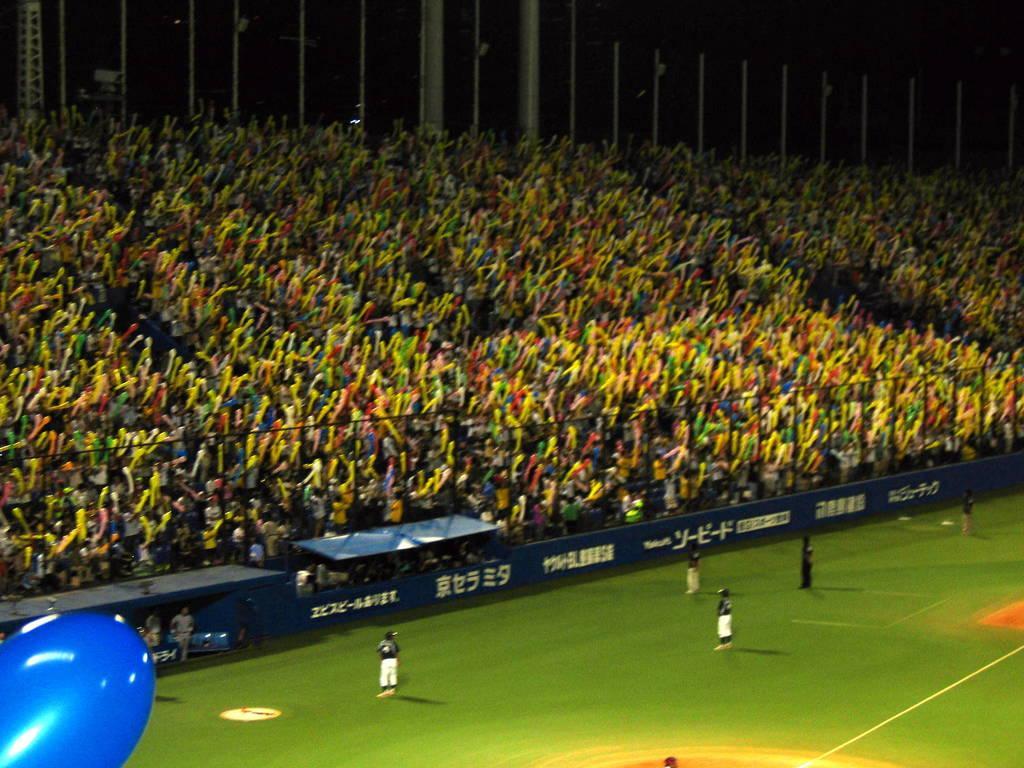In one or two sentences, can you explain what this image depicts? In this image we can see persons standing on the ground and in the stadium. In addition to this we can see advertisement boards, sheds, metal rods and grills. 